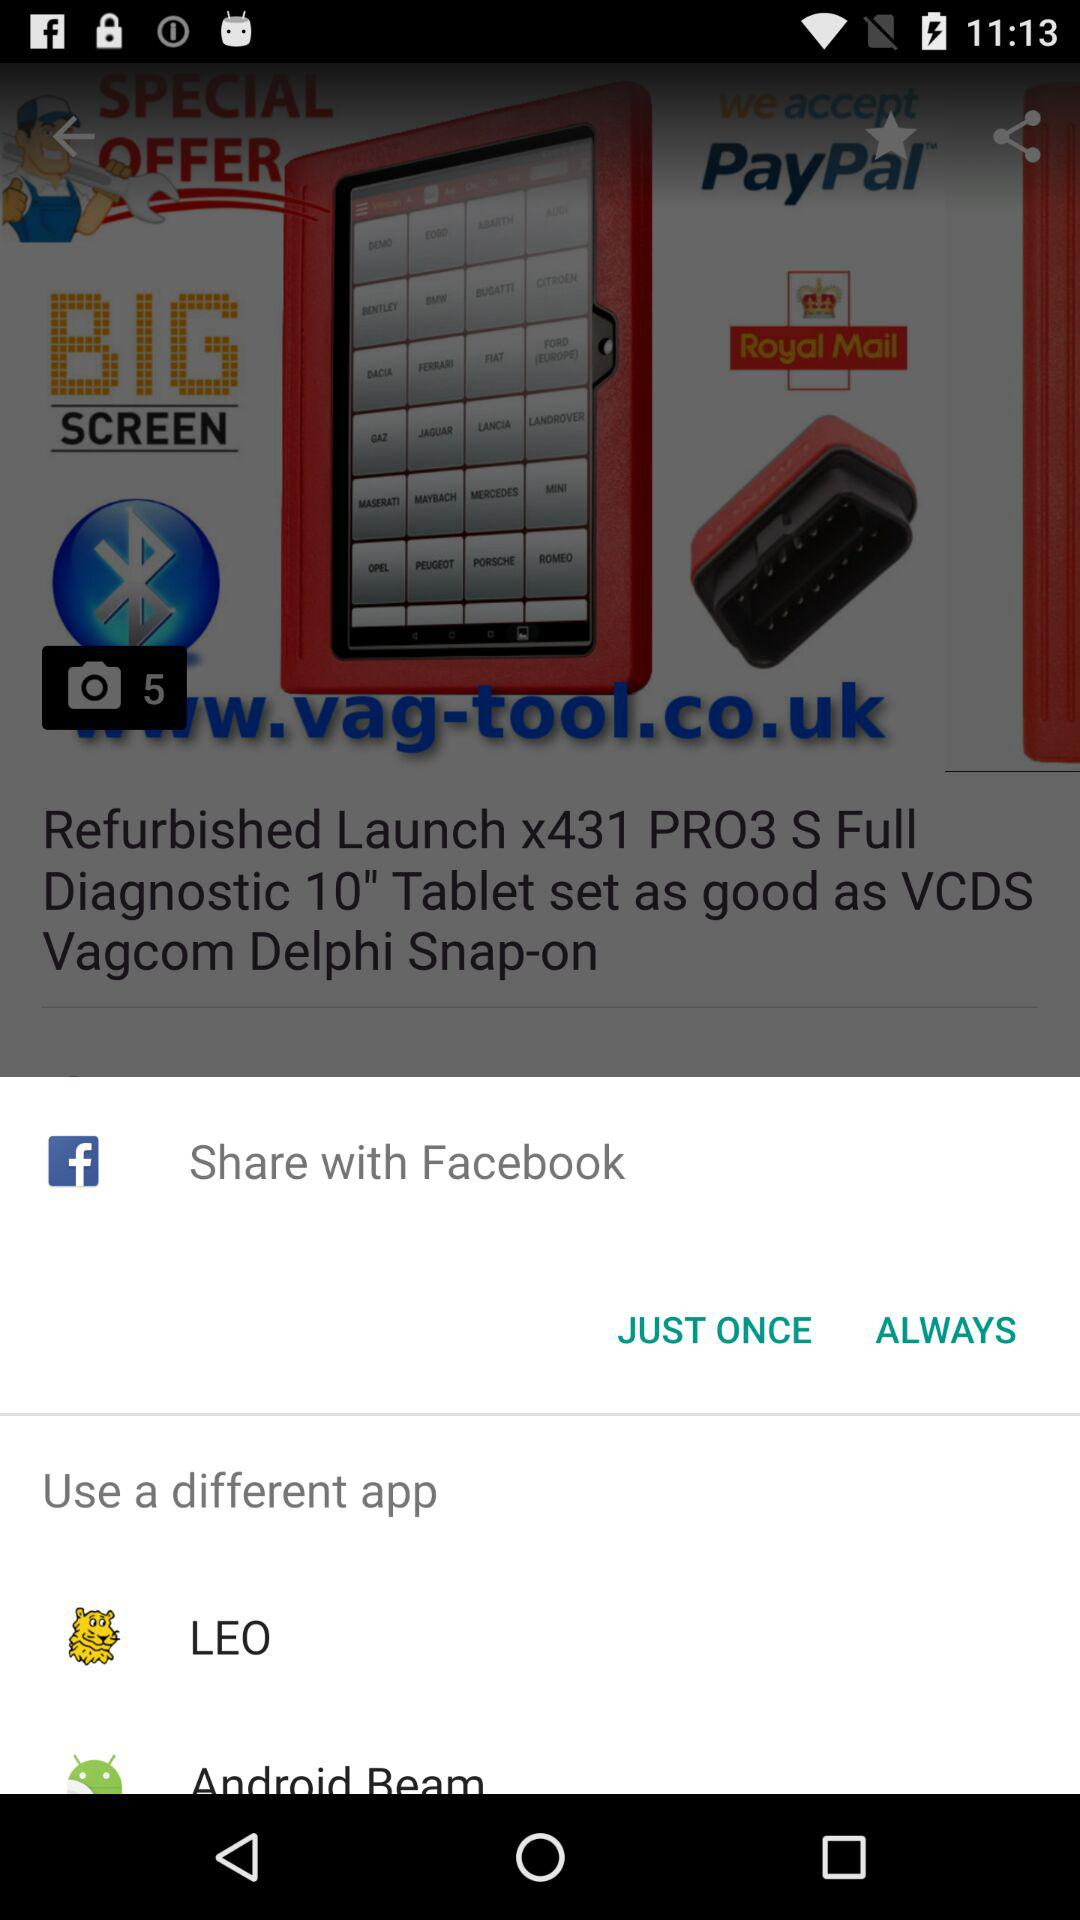What are the options given in "Use a different app"? The options are "LEO" and "Android Beam". 